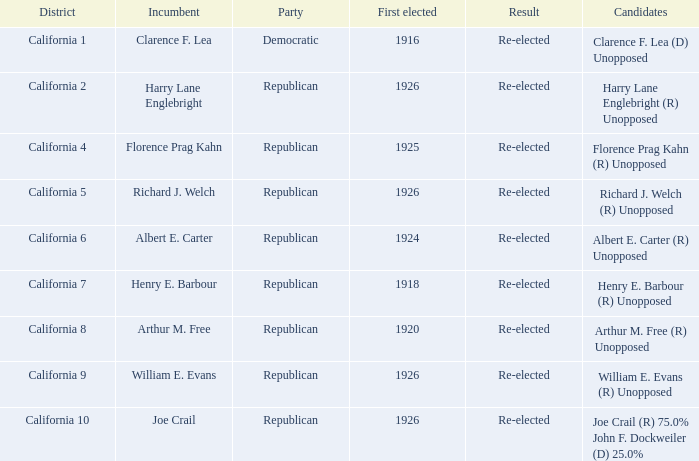What's the political gathering with current holder being william e. evans? Republican. Write the full table. {'header': ['District', 'Incumbent', 'Party', 'First elected', 'Result', 'Candidates'], 'rows': [['California 1', 'Clarence F. Lea', 'Democratic', '1916', 'Re-elected', 'Clarence F. Lea (D) Unopposed'], ['California 2', 'Harry Lane Englebright', 'Republican', '1926', 'Re-elected', 'Harry Lane Englebright (R) Unopposed'], ['California 4', 'Florence Prag Kahn', 'Republican', '1925', 'Re-elected', 'Florence Prag Kahn (R) Unopposed'], ['California 5', 'Richard J. Welch', 'Republican', '1926', 'Re-elected', 'Richard J. Welch (R) Unopposed'], ['California 6', 'Albert E. Carter', 'Republican', '1924', 'Re-elected', 'Albert E. Carter (R) Unopposed'], ['California 7', 'Henry E. Barbour', 'Republican', '1918', 'Re-elected', 'Henry E. Barbour (R) Unopposed'], ['California 8', 'Arthur M. Free', 'Republican', '1920', 'Re-elected', 'Arthur M. Free (R) Unopposed'], ['California 9', 'William E. Evans', 'Republican', '1926', 'Re-elected', 'William E. Evans (R) Unopposed'], ['California 10', 'Joe Crail', 'Republican', '1926', 'Re-elected', 'Joe Crail (R) 75.0% John F. Dockweiler (D) 25.0%']]} 